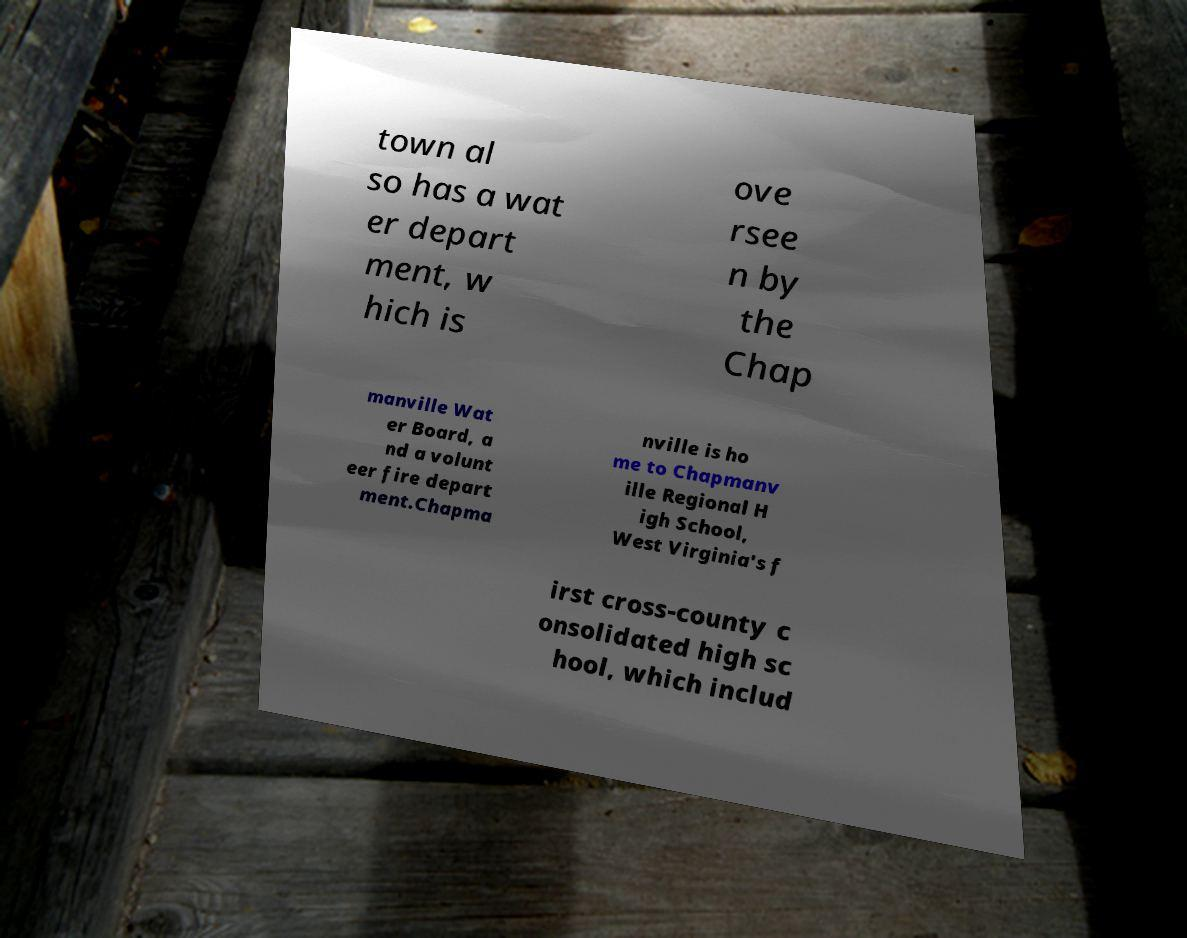I need the written content from this picture converted into text. Can you do that? town al so has a wat er depart ment, w hich is ove rsee n by the Chap manville Wat er Board, a nd a volunt eer fire depart ment.Chapma nville is ho me to Chapmanv ille Regional H igh School, West Virginia's f irst cross-county c onsolidated high sc hool, which includ 